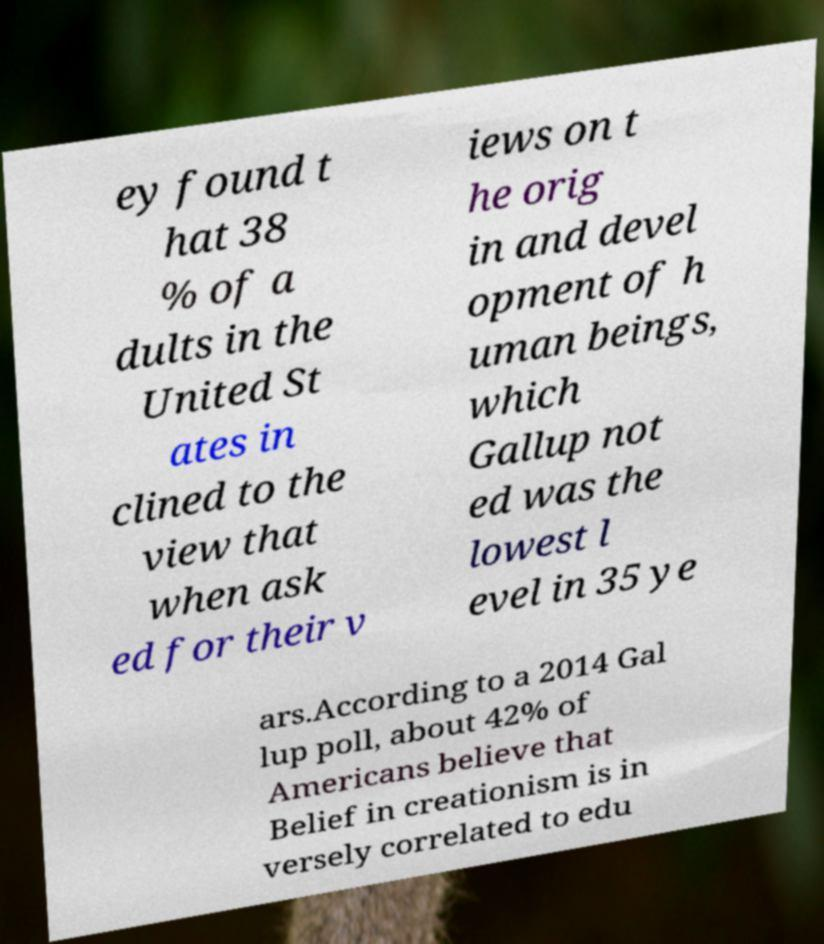Please identify and transcribe the text found in this image. ey found t hat 38 % of a dults in the United St ates in clined to the view that when ask ed for their v iews on t he orig in and devel opment of h uman beings, which Gallup not ed was the lowest l evel in 35 ye ars.According to a 2014 Gal lup poll, about 42% of Americans believe that Belief in creationism is in versely correlated to edu 